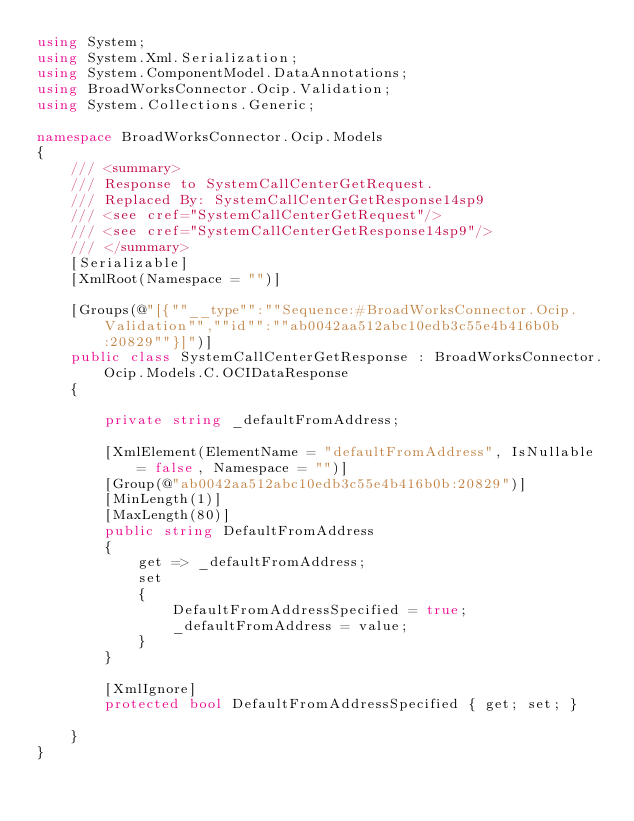<code> <loc_0><loc_0><loc_500><loc_500><_C#_>using System;
using System.Xml.Serialization;
using System.ComponentModel.DataAnnotations;
using BroadWorksConnector.Ocip.Validation;
using System.Collections.Generic;

namespace BroadWorksConnector.Ocip.Models
{
    /// <summary>
    /// Response to SystemCallCenterGetRequest.
    /// Replaced By: SystemCallCenterGetResponse14sp9
    /// <see cref="SystemCallCenterGetRequest"/>
    /// <see cref="SystemCallCenterGetResponse14sp9"/>
    /// </summary>
    [Serializable]
    [XmlRoot(Namespace = "")]

    [Groups(@"[{""__type"":""Sequence:#BroadWorksConnector.Ocip.Validation"",""id"":""ab0042aa512abc10edb3c55e4b416b0b:20829""}]")]
    public class SystemCallCenterGetResponse : BroadWorksConnector.Ocip.Models.C.OCIDataResponse
    {

        private string _defaultFromAddress;

        [XmlElement(ElementName = "defaultFromAddress", IsNullable = false, Namespace = "")]
        [Group(@"ab0042aa512abc10edb3c55e4b416b0b:20829")]
        [MinLength(1)]
        [MaxLength(80)]
        public string DefaultFromAddress
        {
            get => _defaultFromAddress;
            set
            {
                DefaultFromAddressSpecified = true;
                _defaultFromAddress = value;
            }
        }

        [XmlIgnore]
        protected bool DefaultFromAddressSpecified { get; set; }

    }
}
</code> 